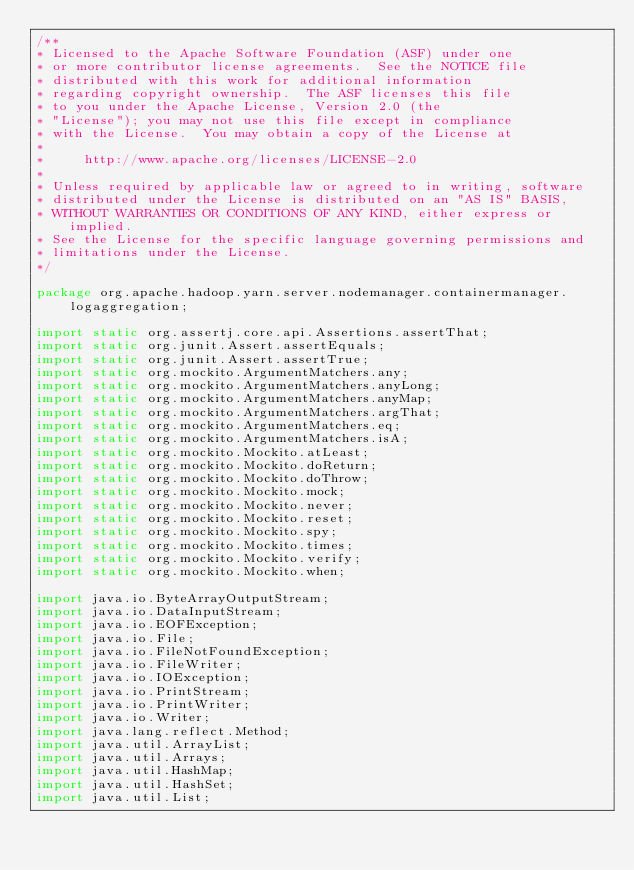<code> <loc_0><loc_0><loc_500><loc_500><_Java_>/**
* Licensed to the Apache Software Foundation (ASF) under one
* or more contributor license agreements.  See the NOTICE file
* distributed with this work for additional information
* regarding copyright ownership.  The ASF licenses this file
* to you under the Apache License, Version 2.0 (the
* "License"); you may not use this file except in compliance
* with the License.  You may obtain a copy of the License at
*
*     http://www.apache.org/licenses/LICENSE-2.0
*
* Unless required by applicable law or agreed to in writing, software
* distributed under the License is distributed on an "AS IS" BASIS,
* WITHOUT WARRANTIES OR CONDITIONS OF ANY KIND, either express or implied.
* See the License for the specific language governing permissions and
* limitations under the License.
*/

package org.apache.hadoop.yarn.server.nodemanager.containermanager.logaggregation;

import static org.assertj.core.api.Assertions.assertThat;
import static org.junit.Assert.assertEquals;
import static org.junit.Assert.assertTrue;
import static org.mockito.ArgumentMatchers.any;
import static org.mockito.ArgumentMatchers.anyLong;
import static org.mockito.ArgumentMatchers.anyMap;
import static org.mockito.ArgumentMatchers.argThat;
import static org.mockito.ArgumentMatchers.eq;
import static org.mockito.ArgumentMatchers.isA;
import static org.mockito.Mockito.atLeast;
import static org.mockito.Mockito.doReturn;
import static org.mockito.Mockito.doThrow;
import static org.mockito.Mockito.mock;
import static org.mockito.Mockito.never;
import static org.mockito.Mockito.reset;
import static org.mockito.Mockito.spy;
import static org.mockito.Mockito.times;
import static org.mockito.Mockito.verify;
import static org.mockito.Mockito.when;

import java.io.ByteArrayOutputStream;
import java.io.DataInputStream;
import java.io.EOFException;
import java.io.File;
import java.io.FileNotFoundException;
import java.io.FileWriter;
import java.io.IOException;
import java.io.PrintStream;
import java.io.PrintWriter;
import java.io.Writer;
import java.lang.reflect.Method;
import java.util.ArrayList;
import java.util.Arrays;
import java.util.HashMap;
import java.util.HashSet;
import java.util.List;</code> 